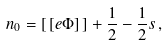Convert formula to latex. <formula><loc_0><loc_0><loc_500><loc_500>n _ { 0 } = [ \, [ e \Phi ] \, ] + \frac { 1 } { 2 } - \frac { 1 } { 2 } s \, ,</formula> 